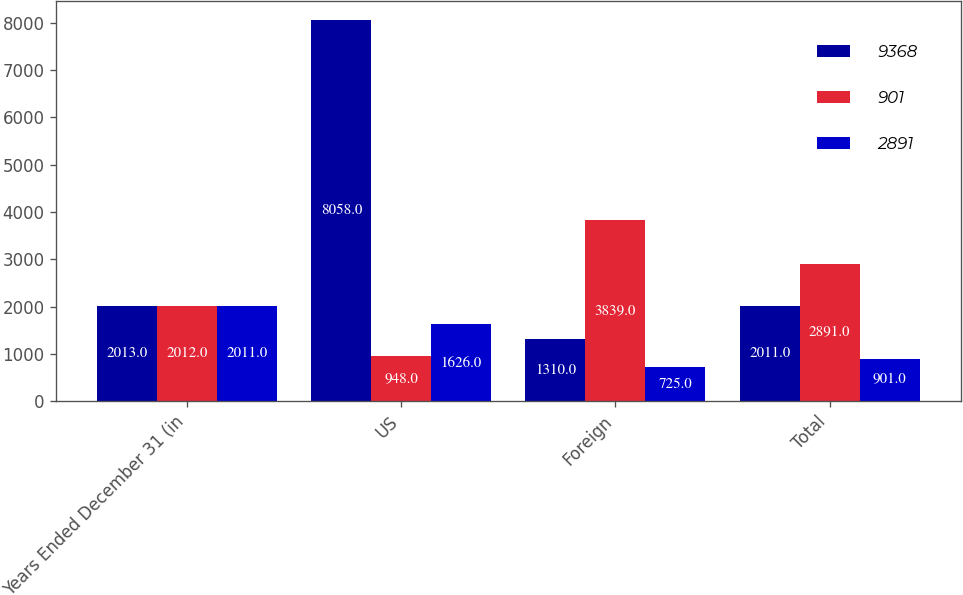Convert chart. <chart><loc_0><loc_0><loc_500><loc_500><stacked_bar_chart><ecel><fcel>Years Ended December 31 (in<fcel>US<fcel>Foreign<fcel>Total<nl><fcel>9368<fcel>2013<fcel>8058<fcel>1310<fcel>2011<nl><fcel>901<fcel>2012<fcel>948<fcel>3839<fcel>2891<nl><fcel>2891<fcel>2011<fcel>1626<fcel>725<fcel>901<nl></chart> 